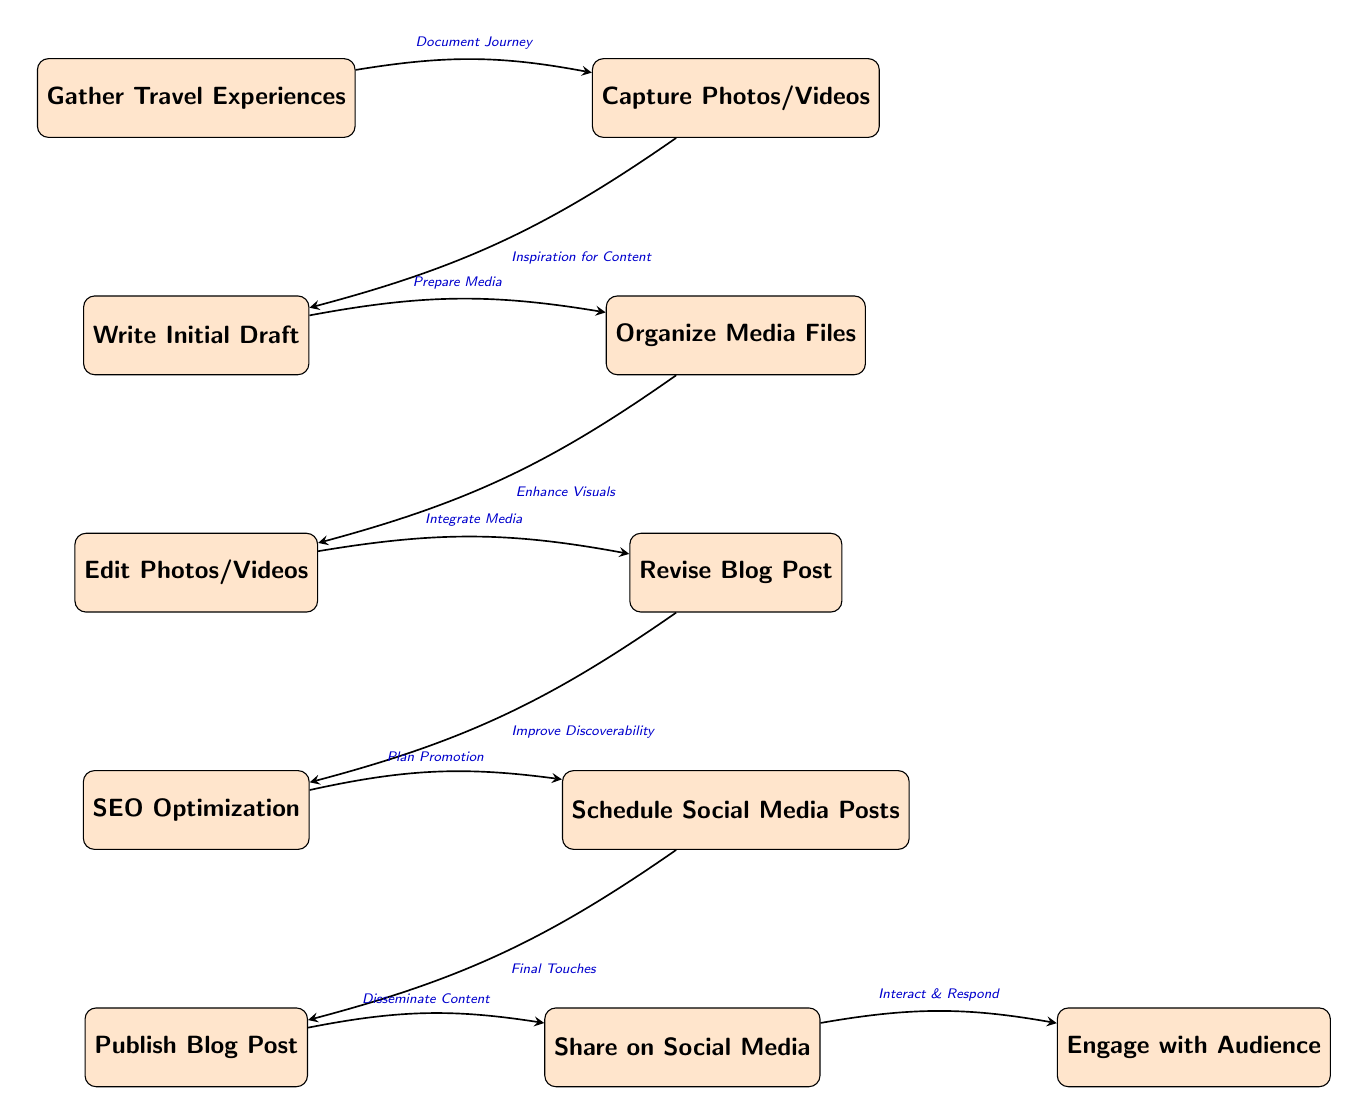What is the first step in the workflow? The first step in the workflow is represented by the top node, which states "Gather Travel Experiences." This node is the starting point of the entire process, as indicated by its position at the top of the diagram.
Answer: Gather Travel Experiences How many nodes are in the diagram? By counting all the distinct colored rectangles in the diagram, we can determine the number of nodes. There are eleven nodes visually represented in total.
Answer: 11 What is the step that follows "Edit Photos/Videos"? To identify the step that follows "Edit Photos/Videos," we look at the connection from the "Edit Photos/Videos" node, which points downward to the next node labeled "SEO Optimization." This node positionally follows the previous one in the flow.
Answer: SEO Optimization What is the relationship between "Capture Photos/Videos" and "Write Initial Draft"? The relationship between these two nodes is indicated by the directed edge connecting them. Specifically, it shows that the output of "Capture Photos/Videos," which is "Inspiration for Content," is a precursor to "Write Initial Draft." Therefore, one leads to the other in the workflow.
Answer: Inspiration for Content What is the last step before publishing the blog post? To determine the last step before "Publish Blog Post," we look immediately above that node in the diagram. It shows "Schedule Social Media Posts" directly connects to "Publish Blog Post." This indicates that scheduling is the final step prior to publishing.
Answer: Schedule Social Media Posts Which node represents improving discoverability? The node specifically labeled "SEO Optimization" is responsible for improving discoverability within the workflow. This is indicated by the flow structure that connects this node after revision.
Answer: SEO Optimization What is the final action taken after publishing a blog post? The action represented following "Publish Blog Post" is found in the next node, which is labeled "Share on Social Media." This indicates the sequence that occurs after publication.
Answer: Share on Social Media Which two steps are directly linked with a downward edge from "Organize Media Files"? The steps that are directly linked with a downward edge from "Organize Media Files" are "Revise Blog Post" and the connecting phrase "Enhance Visuals" from "Edit Photos/Videos." So, "Revise Blog Post" is the next step following "Organize Media Files."
Answer: Revise Blog Post What is the primary focus of the node labeled "Engage with Audience"? The node "Engage with Audience" focuses on interaction after sharing the content on social media and involves responding to the audience's reactions, questions, and comments. This allows for community interaction post-sharing.
Answer: Interact & Respond 